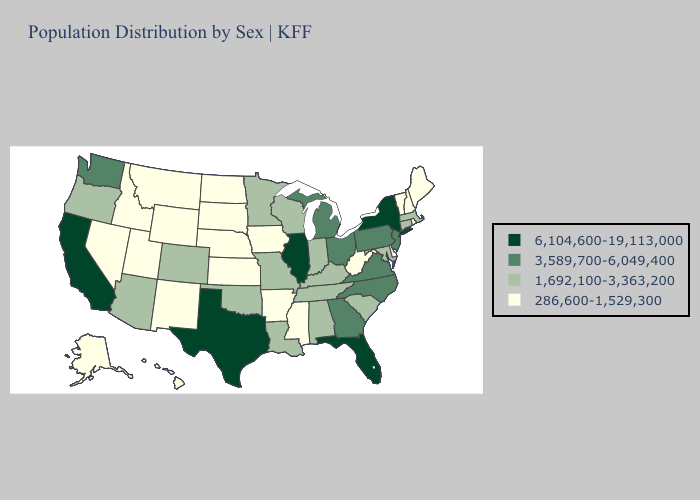Name the states that have a value in the range 6,104,600-19,113,000?
Give a very brief answer. California, Florida, Illinois, New York, Texas. Does Tennessee have the highest value in the USA?
Quick response, please. No. What is the lowest value in the Northeast?
Concise answer only. 286,600-1,529,300. Does Montana have a higher value than Rhode Island?
Concise answer only. No. Name the states that have a value in the range 3,589,700-6,049,400?
Quick response, please. Georgia, Michigan, New Jersey, North Carolina, Ohio, Pennsylvania, Virginia, Washington. Among the states that border Iowa , does Illinois have the highest value?
Keep it brief. Yes. Which states have the highest value in the USA?
Give a very brief answer. California, Florida, Illinois, New York, Texas. What is the value of Arizona?
Keep it brief. 1,692,100-3,363,200. What is the highest value in the Northeast ?
Short answer required. 6,104,600-19,113,000. Name the states that have a value in the range 1,692,100-3,363,200?
Be succinct. Alabama, Arizona, Colorado, Connecticut, Indiana, Kentucky, Louisiana, Maryland, Massachusetts, Minnesota, Missouri, Oklahoma, Oregon, South Carolina, Tennessee, Wisconsin. Name the states that have a value in the range 1,692,100-3,363,200?
Be succinct. Alabama, Arizona, Colorado, Connecticut, Indiana, Kentucky, Louisiana, Maryland, Massachusetts, Minnesota, Missouri, Oklahoma, Oregon, South Carolina, Tennessee, Wisconsin. Does Louisiana have the lowest value in the South?
Concise answer only. No. Name the states that have a value in the range 1,692,100-3,363,200?
Short answer required. Alabama, Arizona, Colorado, Connecticut, Indiana, Kentucky, Louisiana, Maryland, Massachusetts, Minnesota, Missouri, Oklahoma, Oregon, South Carolina, Tennessee, Wisconsin. Which states have the lowest value in the West?
Concise answer only. Alaska, Hawaii, Idaho, Montana, Nevada, New Mexico, Utah, Wyoming. What is the value of New Mexico?
Short answer required. 286,600-1,529,300. 